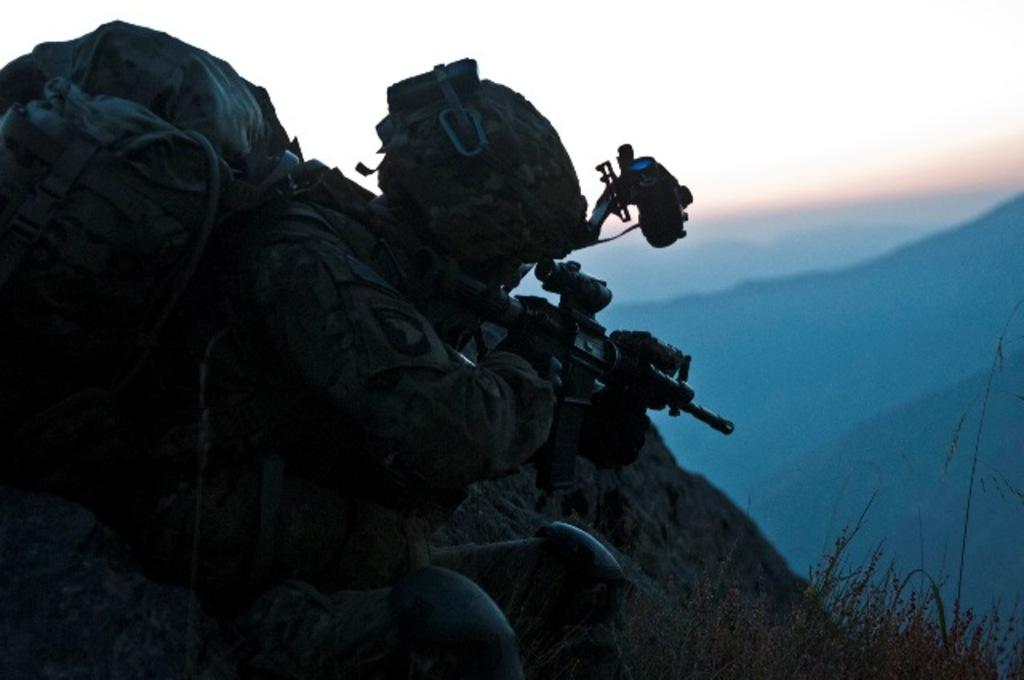What is the man in the image holding? The man is holding a gun. What else is the man carrying in the image? The man is carrying a bag. What type of protective gear is the man wearing? The man is wearing a helmet. What can be seen in the background of the image? There are plants, hills, and the sky visible in the background of the image. What type of camera is the man using to take pictures of the company in the image? There is no camera or company present in the image; the man is holding a gun and carrying a bag. 